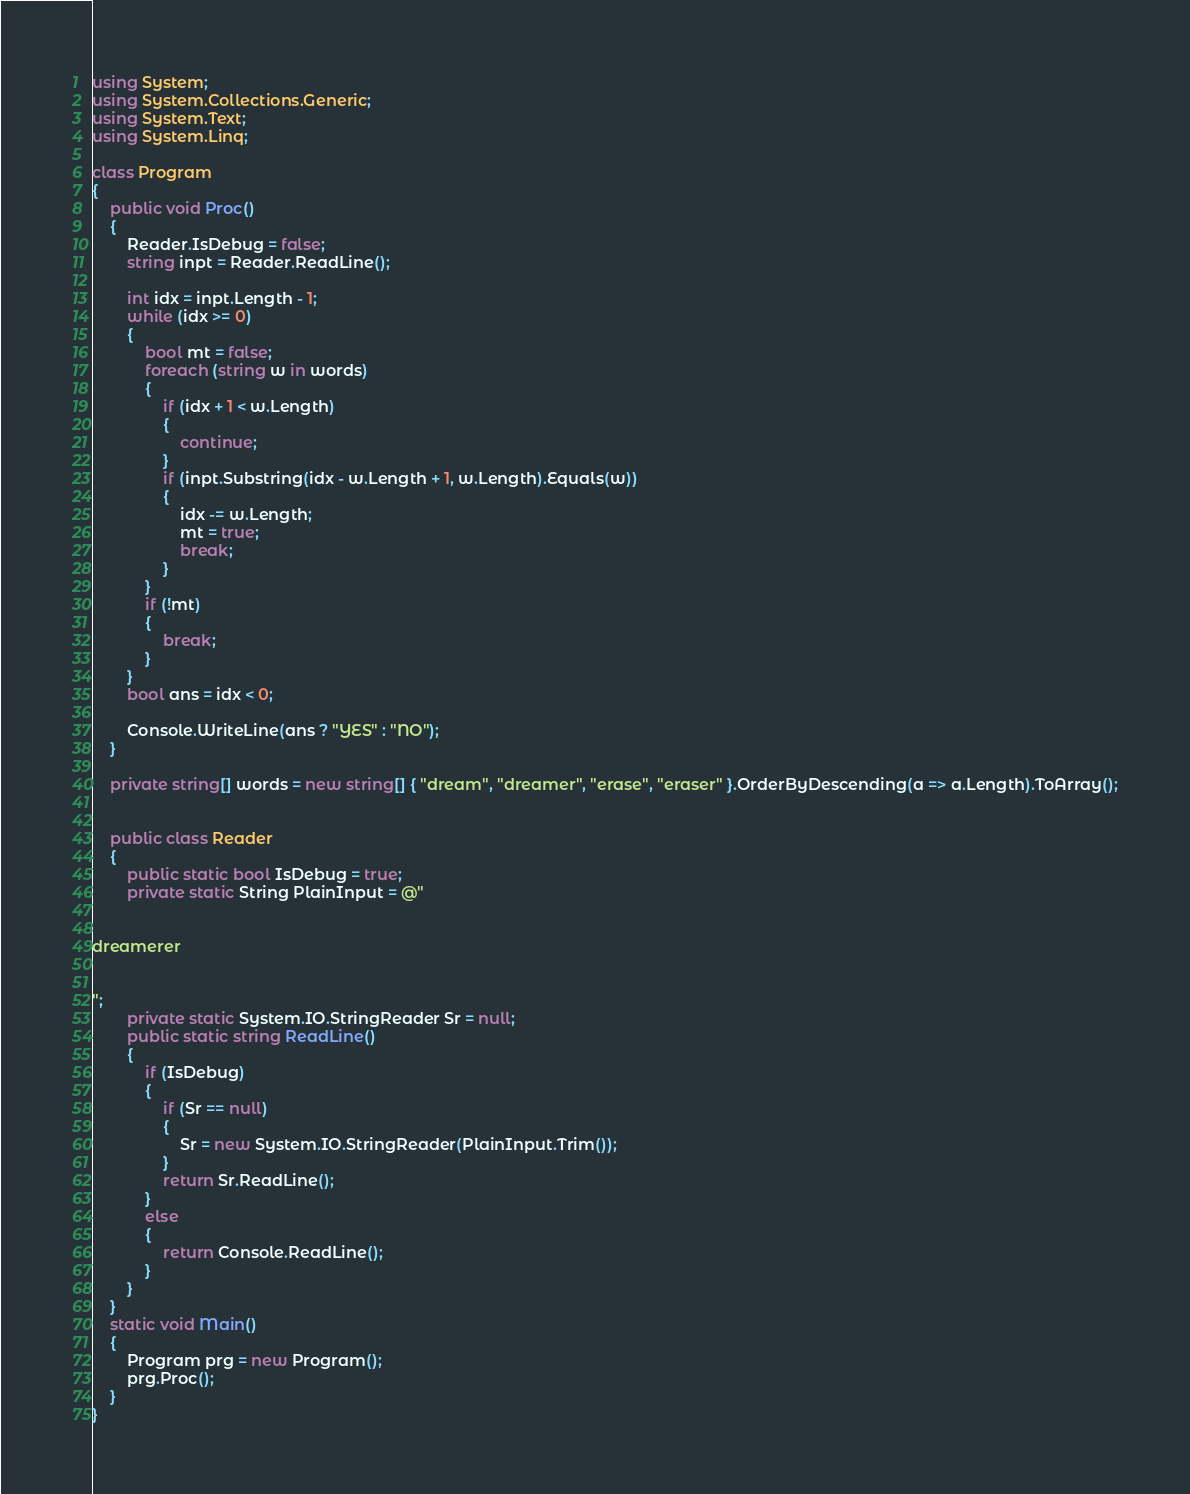Convert code to text. <code><loc_0><loc_0><loc_500><loc_500><_C#_>using System;
using System.Collections.Generic;
using System.Text;
using System.Linq;

class Program
{
    public void Proc()
    {
        Reader.IsDebug = false;
        string inpt = Reader.ReadLine();

        int idx = inpt.Length - 1;
        while (idx >= 0)
        {
            bool mt = false;
            foreach (string w in words)
            {
                if (idx + 1 < w.Length)
                {
                    continue;
                }
                if (inpt.Substring(idx - w.Length + 1, w.Length).Equals(w))
                {
                    idx -= w.Length;
                    mt = true;
                    break;
                }
            }
            if (!mt)
            {
                break;
            }
        }
        bool ans = idx < 0;

        Console.WriteLine(ans ? "YES" : "NO");
    }

    private string[] words = new string[] { "dream", "dreamer", "erase", "eraser" }.OrderByDescending(a => a.Length).ToArray();


    public class Reader
    {
        public static bool IsDebug = true;
        private static String PlainInput = @"

   
dreamerer


";
        private static System.IO.StringReader Sr = null;
        public static string ReadLine()
        {
            if (IsDebug)
            {
                if (Sr == null)
                {
                    Sr = new System.IO.StringReader(PlainInput.Trim());
                }
                return Sr.ReadLine();
            }
            else
            {
                return Console.ReadLine();
            }
        }
    }
    static void Main()
    {
        Program prg = new Program();
        prg.Proc();
    }
}</code> 